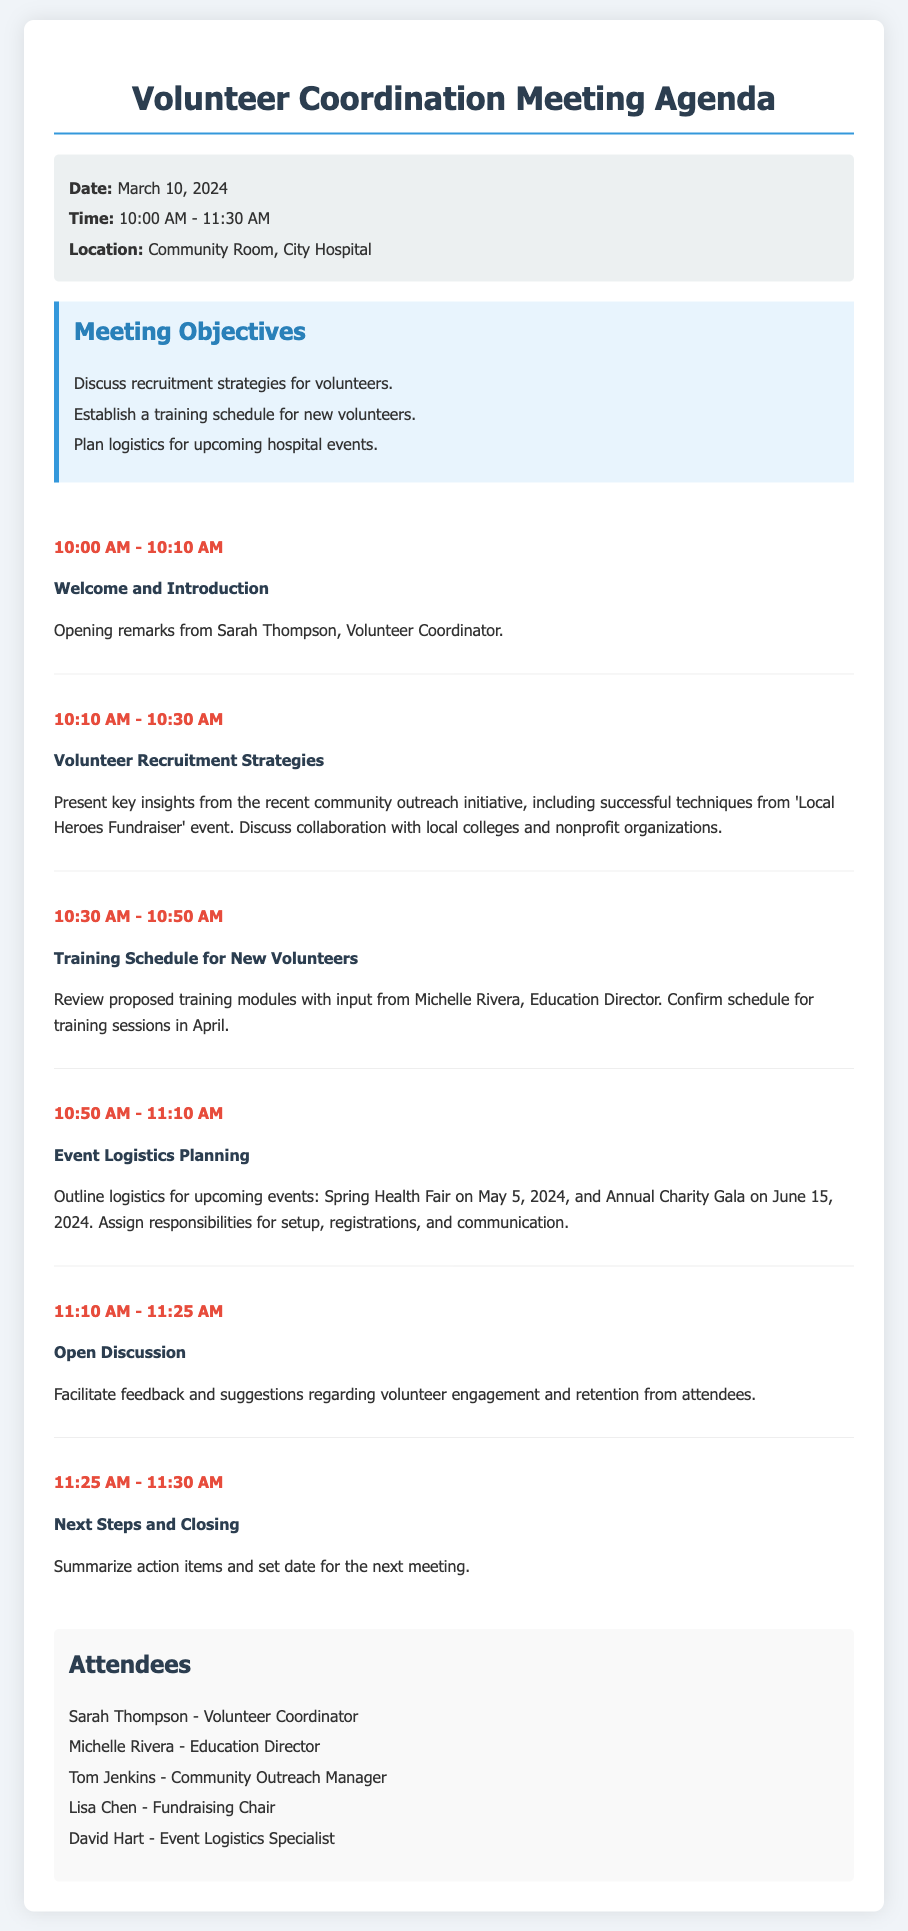What is the date of the meeting? The date of the meeting is specified in the meeting information section of the document.
Answer: March 10, 2024 Who is the Volunteer Coordinator? The Volunteer Coordinator is mentioned in the list of attendees, reflecting their role in the agenda.
Answer: Sarah Thompson What is the time range of the meeting? The meeting's time span is outlined in the meeting information section.
Answer: 10:00 AM - 11:30 AM What is one of the main objectives of the meeting? The objectives of the meeting are presented in a section that lists key goals for discussion.
Answer: Discuss recruitment strategies for volunteers What event is scheduled for May 5, 2024? The event scheduled is noted under the logistics planning item in the agenda.
Answer: Spring Health Fair Who will provide input on the training schedule for new volunteers? The individual who will provide input is noted in the agenda item focused on training.
Answer: Michelle Rivera What time does the open discussion start? The start time for the open discussion is mentioned in the agenda items through time allocations.
Answer: 11:10 AM What is the last agenda item titled? The last agenda item, including time and topic, is specified towards the end of the agenda section.
Answer: Next Steps and Closing How many attendees are listed in the document? The total number of attendees is the count of names specified in the attendees section.
Answer: Five 